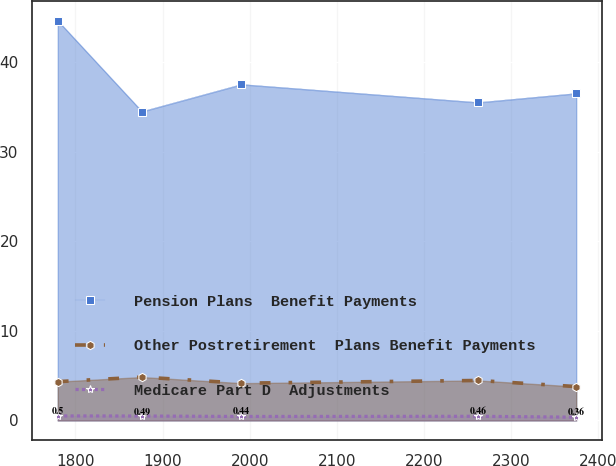Convert chart. <chart><loc_0><loc_0><loc_500><loc_500><line_chart><ecel><fcel>Pension Plans  Benefit Payments<fcel>Other Postretirement  Plans Benefit Payments<fcel>Medicare Part D  Adjustments<nl><fcel>1779.7<fcel>44.64<fcel>4.33<fcel>0.5<nl><fcel>1876.34<fcel>34.5<fcel>4.84<fcel>0.49<nl><fcel>1990.49<fcel>37.53<fcel>4.16<fcel>0.44<nl><fcel>2262.24<fcel>35.51<fcel>4.46<fcel>0.46<nl><fcel>2374.84<fcel>36.52<fcel>3.78<fcel>0.36<nl></chart> 